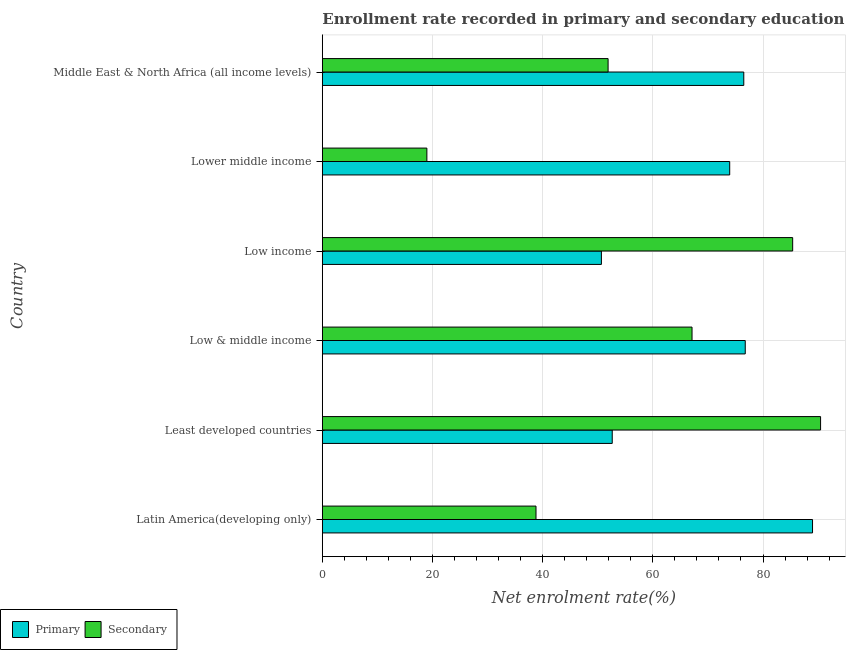Are the number of bars per tick equal to the number of legend labels?
Your response must be concise. Yes. How many bars are there on the 1st tick from the top?
Your answer should be very brief. 2. How many bars are there on the 3rd tick from the bottom?
Provide a succinct answer. 2. What is the label of the 5th group of bars from the top?
Make the answer very short. Least developed countries. What is the enrollment rate in primary education in Low income?
Offer a very short reply. 50.66. Across all countries, what is the maximum enrollment rate in secondary education?
Offer a very short reply. 90.45. Across all countries, what is the minimum enrollment rate in primary education?
Your answer should be compact. 50.66. In which country was the enrollment rate in primary education maximum?
Ensure brevity in your answer.  Latin America(developing only). In which country was the enrollment rate in secondary education minimum?
Offer a very short reply. Lower middle income. What is the total enrollment rate in primary education in the graph?
Offer a terse response. 419.52. What is the difference between the enrollment rate in secondary education in Latin America(developing only) and that in Least developed countries?
Your response must be concise. -51.66. What is the difference between the enrollment rate in secondary education in Least developed countries and the enrollment rate in primary education in Low income?
Keep it short and to the point. 39.79. What is the average enrollment rate in secondary education per country?
Your answer should be very brief. 58.77. What is the difference between the enrollment rate in secondary education and enrollment rate in primary education in Low income?
Keep it short and to the point. 34.72. In how many countries, is the enrollment rate in secondary education greater than 64 %?
Offer a terse response. 3. What is the ratio of the enrollment rate in secondary education in Latin America(developing only) to that in Middle East & North Africa (all income levels)?
Offer a very short reply. 0.75. Is the enrollment rate in secondary education in Least developed countries less than that in Low income?
Make the answer very short. No. What is the difference between the highest and the second highest enrollment rate in secondary education?
Keep it short and to the point. 5.07. What is the difference between the highest and the lowest enrollment rate in secondary education?
Your answer should be compact. 71.47. What does the 1st bar from the top in Least developed countries represents?
Your response must be concise. Secondary. What does the 1st bar from the bottom in Least developed countries represents?
Offer a very short reply. Primary. How many bars are there?
Offer a very short reply. 12. Are all the bars in the graph horizontal?
Give a very brief answer. Yes. How many countries are there in the graph?
Offer a terse response. 6. Are the values on the major ticks of X-axis written in scientific E-notation?
Give a very brief answer. No. Does the graph contain grids?
Provide a short and direct response. Yes. Where does the legend appear in the graph?
Your answer should be compact. Bottom left. How many legend labels are there?
Offer a very short reply. 2. What is the title of the graph?
Make the answer very short. Enrollment rate recorded in primary and secondary education in year 1984. Does "Methane" appear as one of the legend labels in the graph?
Make the answer very short. No. What is the label or title of the X-axis?
Keep it short and to the point. Net enrolment rate(%). What is the Net enrolment rate(%) in Primary in Latin America(developing only)?
Provide a succinct answer. 88.99. What is the Net enrolment rate(%) of Secondary in Latin America(developing only)?
Provide a short and direct response. 38.79. What is the Net enrolment rate(%) of Primary in Least developed countries?
Keep it short and to the point. 52.63. What is the Net enrolment rate(%) of Secondary in Least developed countries?
Keep it short and to the point. 90.45. What is the Net enrolment rate(%) in Primary in Low & middle income?
Give a very brief answer. 76.78. What is the Net enrolment rate(%) in Secondary in Low & middle income?
Your answer should be compact. 67.11. What is the Net enrolment rate(%) in Primary in Low income?
Keep it short and to the point. 50.66. What is the Net enrolment rate(%) of Secondary in Low income?
Your answer should be very brief. 85.38. What is the Net enrolment rate(%) in Primary in Lower middle income?
Your response must be concise. 73.95. What is the Net enrolment rate(%) of Secondary in Lower middle income?
Offer a terse response. 18.98. What is the Net enrolment rate(%) in Primary in Middle East & North Africa (all income levels)?
Provide a succinct answer. 76.51. What is the Net enrolment rate(%) in Secondary in Middle East & North Africa (all income levels)?
Your response must be concise. 51.88. Across all countries, what is the maximum Net enrolment rate(%) of Primary?
Offer a terse response. 88.99. Across all countries, what is the maximum Net enrolment rate(%) of Secondary?
Offer a very short reply. 90.45. Across all countries, what is the minimum Net enrolment rate(%) of Primary?
Give a very brief answer. 50.66. Across all countries, what is the minimum Net enrolment rate(%) in Secondary?
Keep it short and to the point. 18.98. What is the total Net enrolment rate(%) of Primary in the graph?
Make the answer very short. 419.52. What is the total Net enrolment rate(%) of Secondary in the graph?
Offer a terse response. 352.59. What is the difference between the Net enrolment rate(%) of Primary in Latin America(developing only) and that in Least developed countries?
Offer a terse response. 36.36. What is the difference between the Net enrolment rate(%) in Secondary in Latin America(developing only) and that in Least developed countries?
Offer a very short reply. -51.66. What is the difference between the Net enrolment rate(%) in Primary in Latin America(developing only) and that in Low & middle income?
Provide a succinct answer. 12.21. What is the difference between the Net enrolment rate(%) in Secondary in Latin America(developing only) and that in Low & middle income?
Ensure brevity in your answer.  -28.32. What is the difference between the Net enrolment rate(%) of Primary in Latin America(developing only) and that in Low income?
Provide a succinct answer. 38.33. What is the difference between the Net enrolment rate(%) in Secondary in Latin America(developing only) and that in Low income?
Provide a short and direct response. -46.59. What is the difference between the Net enrolment rate(%) of Primary in Latin America(developing only) and that in Lower middle income?
Give a very brief answer. 15.03. What is the difference between the Net enrolment rate(%) in Secondary in Latin America(developing only) and that in Lower middle income?
Give a very brief answer. 19.81. What is the difference between the Net enrolment rate(%) of Primary in Latin America(developing only) and that in Middle East & North Africa (all income levels)?
Your answer should be compact. 12.48. What is the difference between the Net enrolment rate(%) in Secondary in Latin America(developing only) and that in Middle East & North Africa (all income levels)?
Make the answer very short. -13.09. What is the difference between the Net enrolment rate(%) in Primary in Least developed countries and that in Low & middle income?
Your answer should be compact. -24.15. What is the difference between the Net enrolment rate(%) in Secondary in Least developed countries and that in Low & middle income?
Offer a very short reply. 23.34. What is the difference between the Net enrolment rate(%) in Primary in Least developed countries and that in Low income?
Offer a terse response. 1.96. What is the difference between the Net enrolment rate(%) of Secondary in Least developed countries and that in Low income?
Provide a short and direct response. 5.07. What is the difference between the Net enrolment rate(%) of Primary in Least developed countries and that in Lower middle income?
Your response must be concise. -21.33. What is the difference between the Net enrolment rate(%) in Secondary in Least developed countries and that in Lower middle income?
Your answer should be compact. 71.47. What is the difference between the Net enrolment rate(%) in Primary in Least developed countries and that in Middle East & North Africa (all income levels)?
Provide a short and direct response. -23.88. What is the difference between the Net enrolment rate(%) in Secondary in Least developed countries and that in Middle East & North Africa (all income levels)?
Offer a terse response. 38.57. What is the difference between the Net enrolment rate(%) in Primary in Low & middle income and that in Low income?
Your answer should be very brief. 26.11. What is the difference between the Net enrolment rate(%) in Secondary in Low & middle income and that in Low income?
Make the answer very short. -18.27. What is the difference between the Net enrolment rate(%) of Primary in Low & middle income and that in Lower middle income?
Provide a short and direct response. 2.82. What is the difference between the Net enrolment rate(%) in Secondary in Low & middle income and that in Lower middle income?
Give a very brief answer. 48.13. What is the difference between the Net enrolment rate(%) in Primary in Low & middle income and that in Middle East & North Africa (all income levels)?
Make the answer very short. 0.27. What is the difference between the Net enrolment rate(%) of Secondary in Low & middle income and that in Middle East & North Africa (all income levels)?
Give a very brief answer. 15.24. What is the difference between the Net enrolment rate(%) in Primary in Low income and that in Lower middle income?
Make the answer very short. -23.29. What is the difference between the Net enrolment rate(%) of Secondary in Low income and that in Lower middle income?
Give a very brief answer. 66.4. What is the difference between the Net enrolment rate(%) in Primary in Low income and that in Middle East & North Africa (all income levels)?
Make the answer very short. -25.85. What is the difference between the Net enrolment rate(%) of Secondary in Low income and that in Middle East & North Africa (all income levels)?
Your answer should be very brief. 33.51. What is the difference between the Net enrolment rate(%) in Primary in Lower middle income and that in Middle East & North Africa (all income levels)?
Your answer should be very brief. -2.56. What is the difference between the Net enrolment rate(%) of Secondary in Lower middle income and that in Middle East & North Africa (all income levels)?
Offer a very short reply. -32.9. What is the difference between the Net enrolment rate(%) in Primary in Latin America(developing only) and the Net enrolment rate(%) in Secondary in Least developed countries?
Provide a short and direct response. -1.46. What is the difference between the Net enrolment rate(%) of Primary in Latin America(developing only) and the Net enrolment rate(%) of Secondary in Low & middle income?
Give a very brief answer. 21.88. What is the difference between the Net enrolment rate(%) of Primary in Latin America(developing only) and the Net enrolment rate(%) of Secondary in Low income?
Give a very brief answer. 3.61. What is the difference between the Net enrolment rate(%) of Primary in Latin America(developing only) and the Net enrolment rate(%) of Secondary in Lower middle income?
Offer a terse response. 70.01. What is the difference between the Net enrolment rate(%) in Primary in Latin America(developing only) and the Net enrolment rate(%) in Secondary in Middle East & North Africa (all income levels)?
Give a very brief answer. 37.11. What is the difference between the Net enrolment rate(%) in Primary in Least developed countries and the Net enrolment rate(%) in Secondary in Low & middle income?
Offer a very short reply. -14.49. What is the difference between the Net enrolment rate(%) in Primary in Least developed countries and the Net enrolment rate(%) in Secondary in Low income?
Offer a very short reply. -32.76. What is the difference between the Net enrolment rate(%) in Primary in Least developed countries and the Net enrolment rate(%) in Secondary in Lower middle income?
Offer a terse response. 33.65. What is the difference between the Net enrolment rate(%) of Primary in Least developed countries and the Net enrolment rate(%) of Secondary in Middle East & North Africa (all income levels)?
Offer a very short reply. 0.75. What is the difference between the Net enrolment rate(%) in Primary in Low & middle income and the Net enrolment rate(%) in Secondary in Low income?
Give a very brief answer. -8.61. What is the difference between the Net enrolment rate(%) of Primary in Low & middle income and the Net enrolment rate(%) of Secondary in Lower middle income?
Your response must be concise. 57.8. What is the difference between the Net enrolment rate(%) in Primary in Low & middle income and the Net enrolment rate(%) in Secondary in Middle East & North Africa (all income levels)?
Provide a succinct answer. 24.9. What is the difference between the Net enrolment rate(%) in Primary in Low income and the Net enrolment rate(%) in Secondary in Lower middle income?
Your answer should be compact. 31.68. What is the difference between the Net enrolment rate(%) in Primary in Low income and the Net enrolment rate(%) in Secondary in Middle East & North Africa (all income levels)?
Ensure brevity in your answer.  -1.21. What is the difference between the Net enrolment rate(%) in Primary in Lower middle income and the Net enrolment rate(%) in Secondary in Middle East & North Africa (all income levels)?
Give a very brief answer. 22.08. What is the average Net enrolment rate(%) in Primary per country?
Give a very brief answer. 69.92. What is the average Net enrolment rate(%) of Secondary per country?
Offer a terse response. 58.76. What is the difference between the Net enrolment rate(%) in Primary and Net enrolment rate(%) in Secondary in Latin America(developing only)?
Your answer should be compact. 50.2. What is the difference between the Net enrolment rate(%) of Primary and Net enrolment rate(%) of Secondary in Least developed countries?
Keep it short and to the point. -37.82. What is the difference between the Net enrolment rate(%) of Primary and Net enrolment rate(%) of Secondary in Low & middle income?
Offer a terse response. 9.66. What is the difference between the Net enrolment rate(%) of Primary and Net enrolment rate(%) of Secondary in Low income?
Make the answer very short. -34.72. What is the difference between the Net enrolment rate(%) in Primary and Net enrolment rate(%) in Secondary in Lower middle income?
Make the answer very short. 54.97. What is the difference between the Net enrolment rate(%) in Primary and Net enrolment rate(%) in Secondary in Middle East & North Africa (all income levels)?
Keep it short and to the point. 24.63. What is the ratio of the Net enrolment rate(%) in Primary in Latin America(developing only) to that in Least developed countries?
Provide a succinct answer. 1.69. What is the ratio of the Net enrolment rate(%) in Secondary in Latin America(developing only) to that in Least developed countries?
Provide a succinct answer. 0.43. What is the ratio of the Net enrolment rate(%) of Primary in Latin America(developing only) to that in Low & middle income?
Make the answer very short. 1.16. What is the ratio of the Net enrolment rate(%) of Secondary in Latin America(developing only) to that in Low & middle income?
Offer a terse response. 0.58. What is the ratio of the Net enrolment rate(%) of Primary in Latin America(developing only) to that in Low income?
Offer a terse response. 1.76. What is the ratio of the Net enrolment rate(%) of Secondary in Latin America(developing only) to that in Low income?
Ensure brevity in your answer.  0.45. What is the ratio of the Net enrolment rate(%) of Primary in Latin America(developing only) to that in Lower middle income?
Make the answer very short. 1.2. What is the ratio of the Net enrolment rate(%) of Secondary in Latin America(developing only) to that in Lower middle income?
Ensure brevity in your answer.  2.04. What is the ratio of the Net enrolment rate(%) of Primary in Latin America(developing only) to that in Middle East & North Africa (all income levels)?
Provide a succinct answer. 1.16. What is the ratio of the Net enrolment rate(%) of Secondary in Latin America(developing only) to that in Middle East & North Africa (all income levels)?
Keep it short and to the point. 0.75. What is the ratio of the Net enrolment rate(%) of Primary in Least developed countries to that in Low & middle income?
Make the answer very short. 0.69. What is the ratio of the Net enrolment rate(%) in Secondary in Least developed countries to that in Low & middle income?
Give a very brief answer. 1.35. What is the ratio of the Net enrolment rate(%) in Primary in Least developed countries to that in Low income?
Offer a terse response. 1.04. What is the ratio of the Net enrolment rate(%) in Secondary in Least developed countries to that in Low income?
Provide a succinct answer. 1.06. What is the ratio of the Net enrolment rate(%) in Primary in Least developed countries to that in Lower middle income?
Your answer should be compact. 0.71. What is the ratio of the Net enrolment rate(%) of Secondary in Least developed countries to that in Lower middle income?
Ensure brevity in your answer.  4.77. What is the ratio of the Net enrolment rate(%) in Primary in Least developed countries to that in Middle East & North Africa (all income levels)?
Provide a succinct answer. 0.69. What is the ratio of the Net enrolment rate(%) in Secondary in Least developed countries to that in Middle East & North Africa (all income levels)?
Ensure brevity in your answer.  1.74. What is the ratio of the Net enrolment rate(%) in Primary in Low & middle income to that in Low income?
Give a very brief answer. 1.52. What is the ratio of the Net enrolment rate(%) of Secondary in Low & middle income to that in Low income?
Keep it short and to the point. 0.79. What is the ratio of the Net enrolment rate(%) of Primary in Low & middle income to that in Lower middle income?
Provide a succinct answer. 1.04. What is the ratio of the Net enrolment rate(%) in Secondary in Low & middle income to that in Lower middle income?
Provide a short and direct response. 3.54. What is the ratio of the Net enrolment rate(%) of Secondary in Low & middle income to that in Middle East & North Africa (all income levels)?
Provide a succinct answer. 1.29. What is the ratio of the Net enrolment rate(%) in Primary in Low income to that in Lower middle income?
Offer a very short reply. 0.69. What is the ratio of the Net enrolment rate(%) in Secondary in Low income to that in Lower middle income?
Offer a terse response. 4.5. What is the ratio of the Net enrolment rate(%) in Primary in Low income to that in Middle East & North Africa (all income levels)?
Your response must be concise. 0.66. What is the ratio of the Net enrolment rate(%) of Secondary in Low income to that in Middle East & North Africa (all income levels)?
Ensure brevity in your answer.  1.65. What is the ratio of the Net enrolment rate(%) in Primary in Lower middle income to that in Middle East & North Africa (all income levels)?
Keep it short and to the point. 0.97. What is the ratio of the Net enrolment rate(%) of Secondary in Lower middle income to that in Middle East & North Africa (all income levels)?
Give a very brief answer. 0.37. What is the difference between the highest and the second highest Net enrolment rate(%) of Primary?
Provide a succinct answer. 12.21. What is the difference between the highest and the second highest Net enrolment rate(%) in Secondary?
Your answer should be compact. 5.07. What is the difference between the highest and the lowest Net enrolment rate(%) of Primary?
Provide a succinct answer. 38.33. What is the difference between the highest and the lowest Net enrolment rate(%) of Secondary?
Provide a succinct answer. 71.47. 